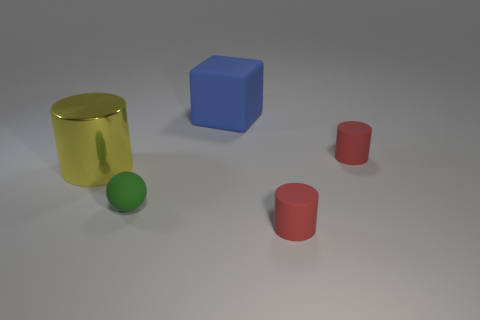What number of other things are there of the same size as the green matte ball? There are two objects that appear to be of comparable size to the green matte ball: the two red cylindrical objects. 